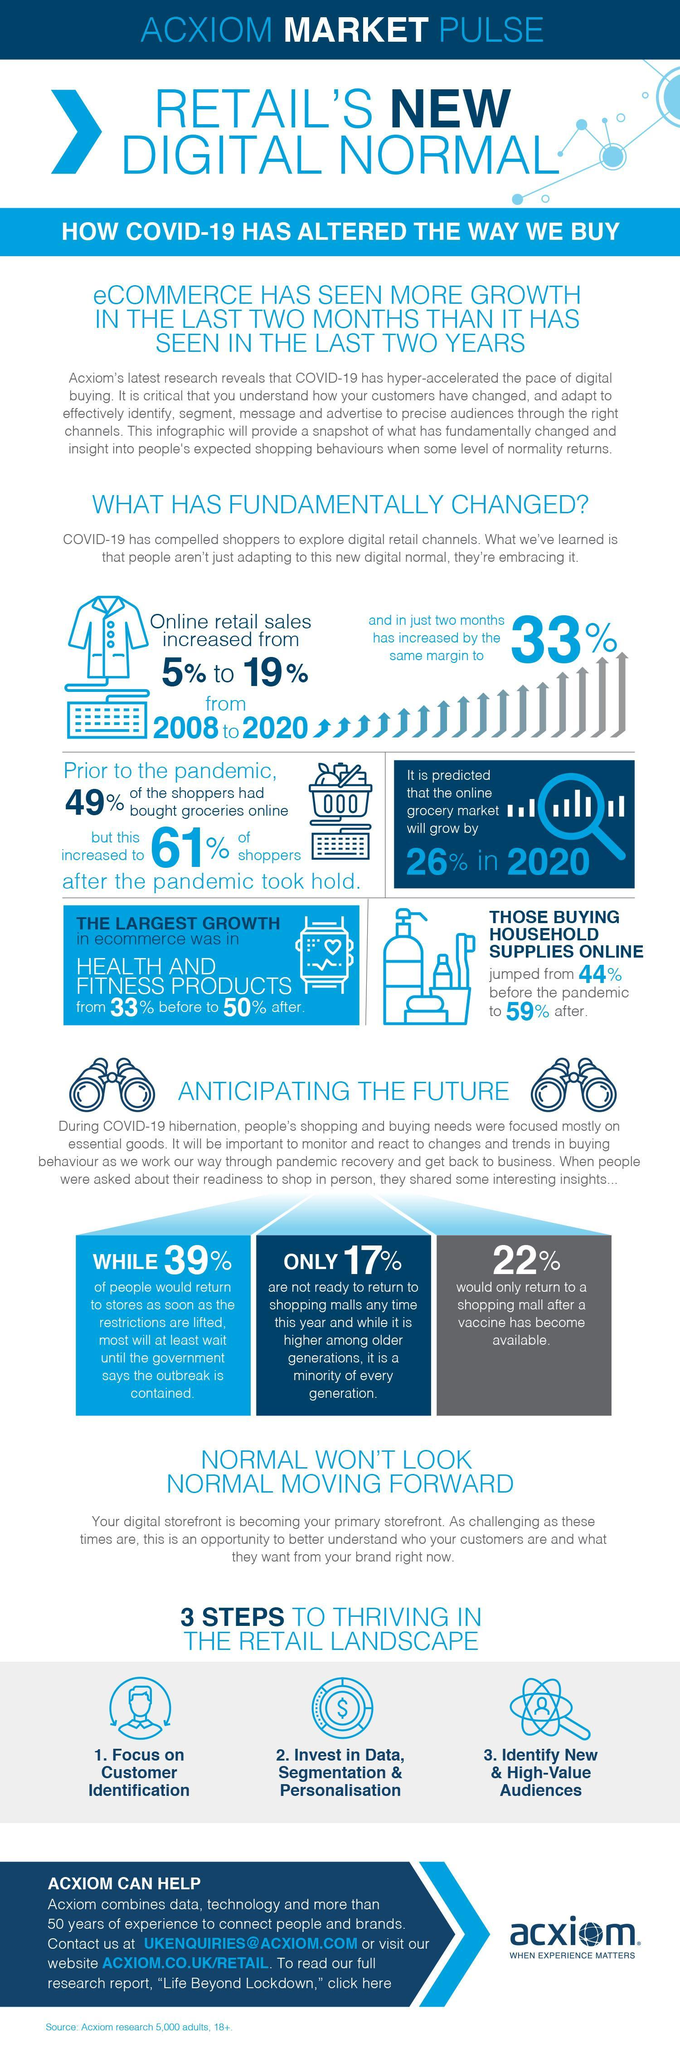What percentage of people would only return to a shopping mall after a vaccine for Covid-19 has become available?
Answer the question with a short phrase. 22% What is the percentage increase predicted in the online grocery market in 2020? 26% What percentage of people prefer buying household supplies online after the Covid -19 outbreak in 2020? 59% Whs percentage of people would return to stores as soon as the government restrictions are lifted? 39% 